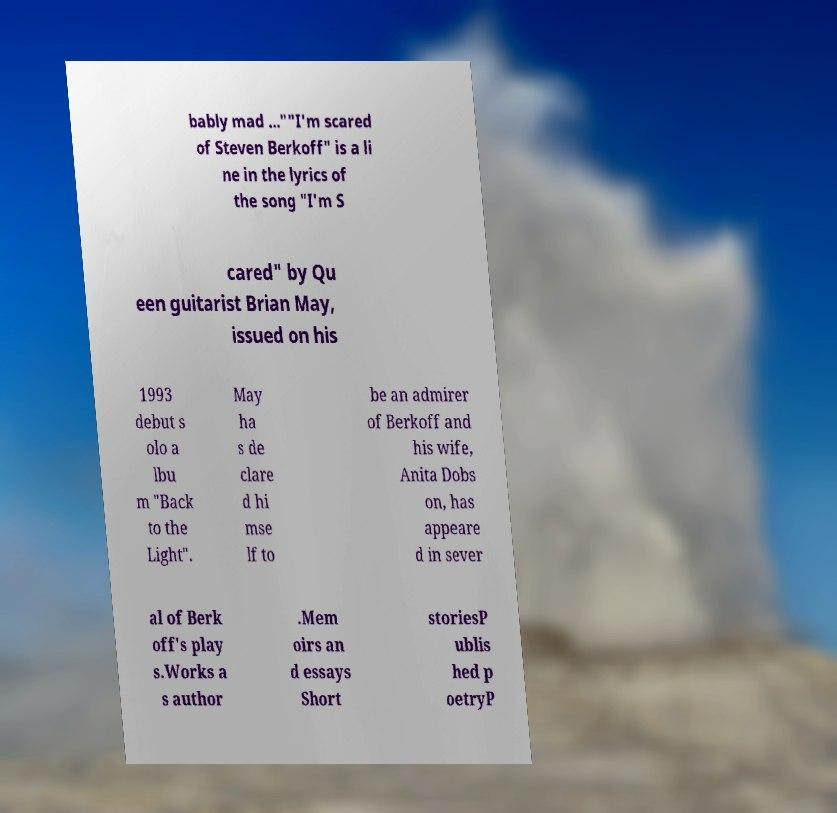Please read and relay the text visible in this image. What does it say? bably mad ...""I'm scared of Steven Berkoff" is a li ne in the lyrics of the song "I'm S cared" by Qu een guitarist Brian May, issued on his 1993 debut s olo a lbu m "Back to the Light". May ha s de clare d hi mse lf to be an admirer of Berkoff and his wife, Anita Dobs on, has appeare d in sever al of Berk off's play s.Works a s author .Mem oirs an d essays Short storiesP ublis hed p oetryP 